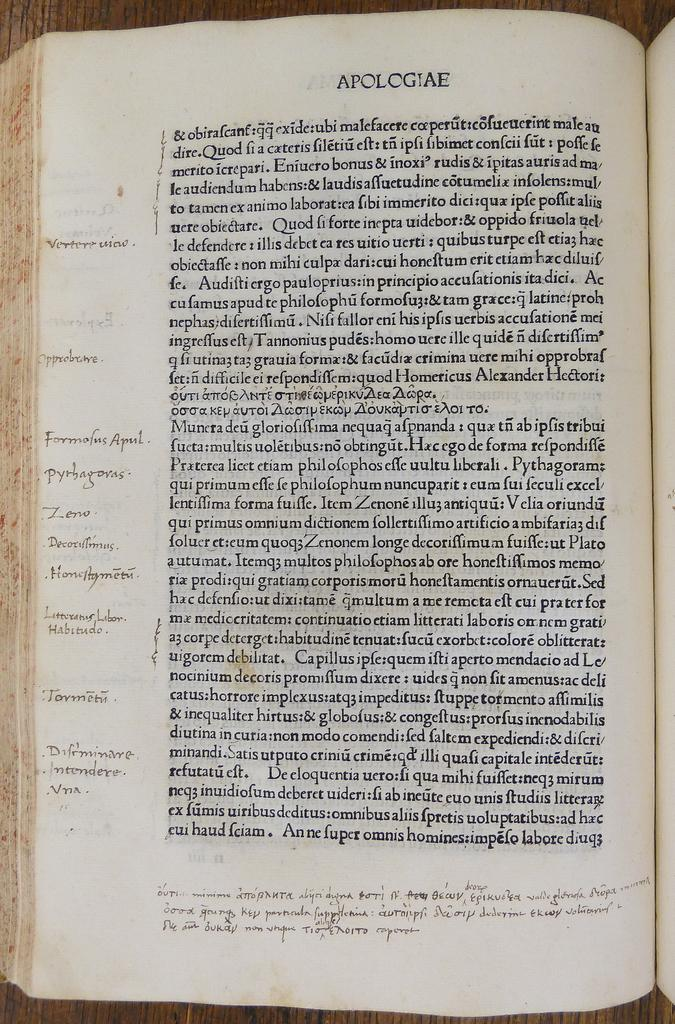<image>
Share a concise interpretation of the image provided. An old book with the edges of the pages worn and written on, is open to the page that says Apologiae at the top. 